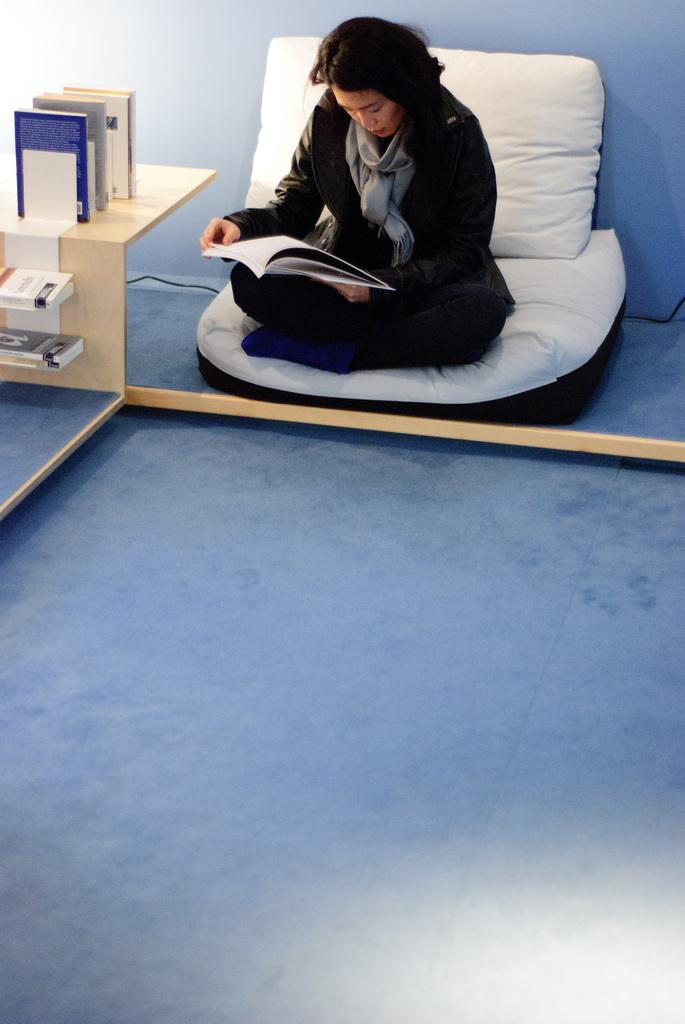What type of space is depicted in the image? The image shows the inner view of a room. Is there anyone present in the room? Yes, there is a person sitting in the room. What is the person doing in the image? The person is holding a book. What furniture can be seen in the room? There is a table in the room. Are there any books on the table? Yes, the table has some books on it. Can you see an owl perched on the bookshelf in the image? There is no owl or bookshelf present in the image. Is the person wearing a chain around their neck in the image? There is no chain visible around the person's neck in the image. 